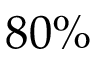Convert formula to latex. <formula><loc_0><loc_0><loc_500><loc_500>8 0 \%</formula> 